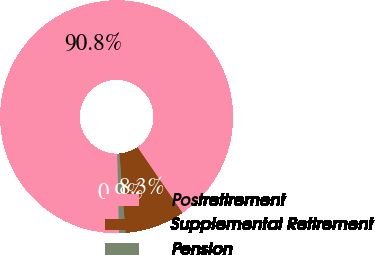Convert chart to OTSL. <chart><loc_0><loc_0><loc_500><loc_500><pie_chart><fcel>Postretirement<fcel>Supplemental Retirement<fcel>Pension<nl><fcel>90.79%<fcel>8.32%<fcel>0.89%<nl></chart> 